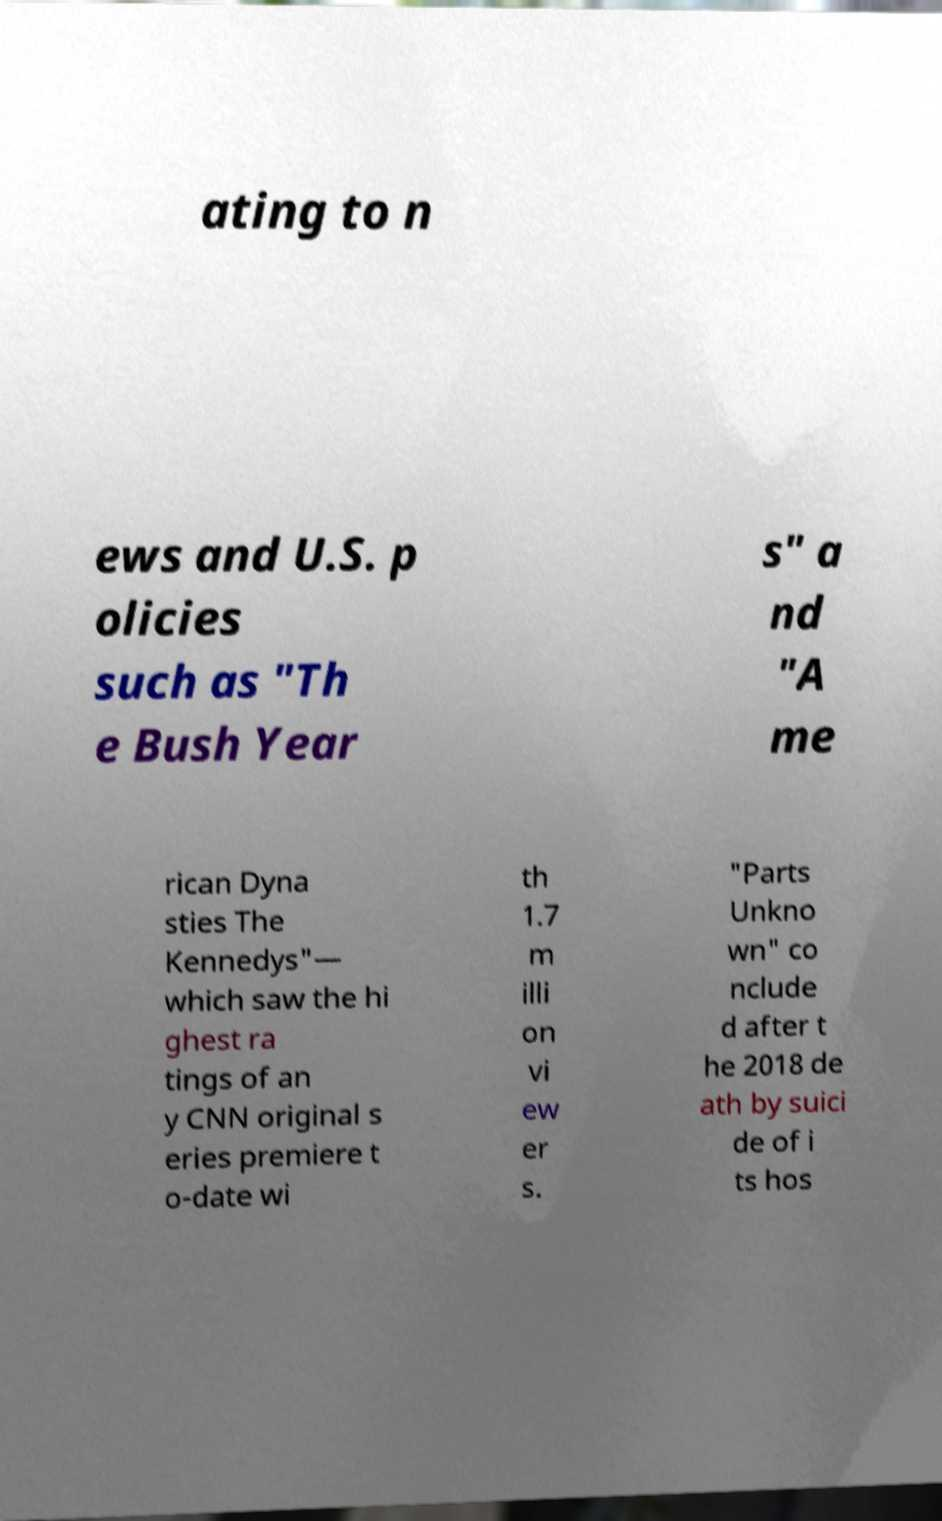Please identify and transcribe the text found in this image. ating to n ews and U.S. p olicies such as "Th e Bush Year s" a nd "A me rican Dyna sties The Kennedys"— which saw the hi ghest ra tings of an y CNN original s eries premiere t o-date wi th 1.7 m illi on vi ew er s. "Parts Unkno wn" co nclude d after t he 2018 de ath by suici de of i ts hos 